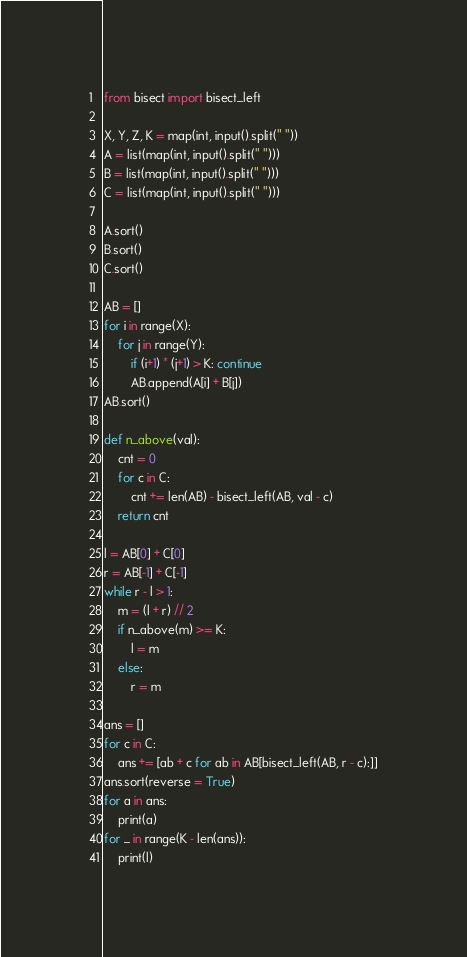<code> <loc_0><loc_0><loc_500><loc_500><_Python_>from bisect import bisect_left

X, Y, Z, K = map(int, input().split(" "))
A = list(map(int, input().split(" ")))
B = list(map(int, input().split(" ")))
C = list(map(int, input().split(" ")))

A.sort()
B.sort()
C.sort()

AB = []
for i in range(X):
    for j in range(Y):
        if (i+1) * (j+1) > K: continue
        AB.append(A[i] + B[j])
AB.sort()

def n_above(val):
    cnt = 0
    for c in C:
        cnt += len(AB) - bisect_left(AB, val - c)
    return cnt

l = AB[0] + C[0]
r = AB[-1] + C[-1]
while r - l > 1:
    m = (l + r) // 2
    if n_above(m) >= K:
        l = m
    else:
        r = m

ans = []
for c in C:
    ans += [ab + c for ab in AB[bisect_left(AB, r - c):]]
ans.sort(reverse = True)
for a in ans:
    print(a)
for _ in range(K - len(ans)):
    print(l)</code> 